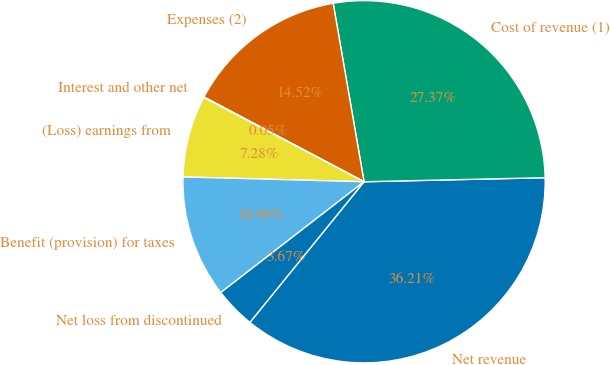<chart> <loc_0><loc_0><loc_500><loc_500><pie_chart><fcel>Net revenue<fcel>Cost of revenue (1)<fcel>Expenses (2)<fcel>Interest and other net<fcel>(Loss) earnings from<fcel>Benefit (provision) for taxes<fcel>Net loss from discontinued<nl><fcel>36.21%<fcel>27.37%<fcel>14.52%<fcel>0.05%<fcel>7.28%<fcel>10.9%<fcel>3.67%<nl></chart> 